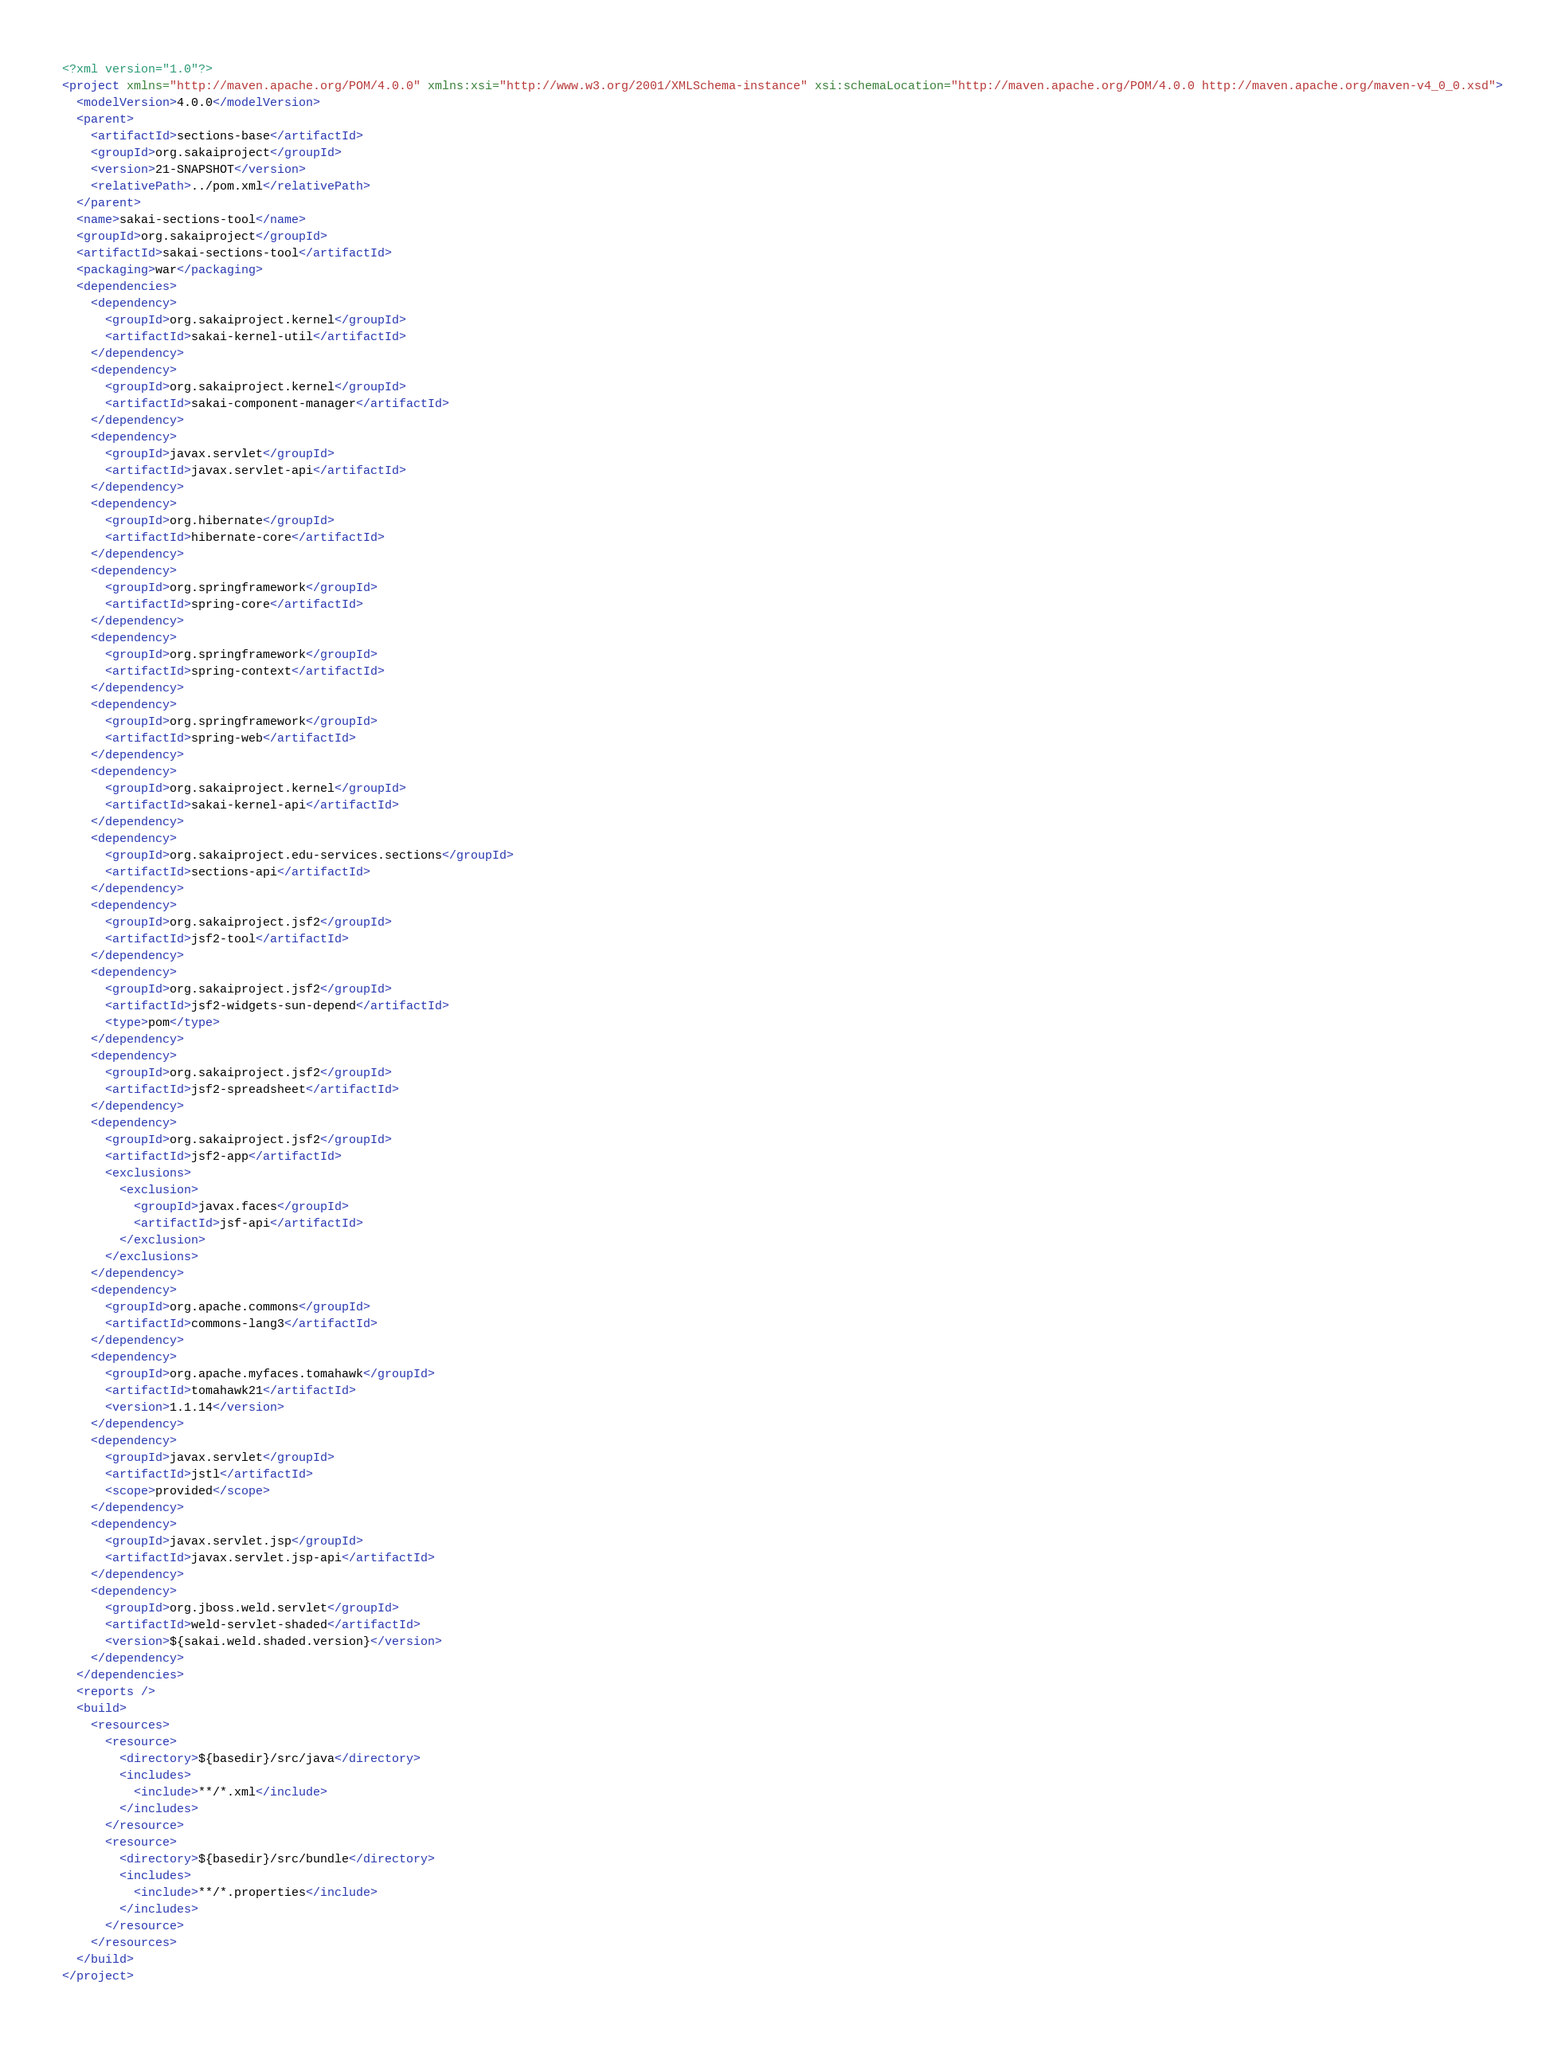Convert code to text. <code><loc_0><loc_0><loc_500><loc_500><_XML_><?xml version="1.0"?>
<project xmlns="http://maven.apache.org/POM/4.0.0" xmlns:xsi="http://www.w3.org/2001/XMLSchema-instance" xsi:schemaLocation="http://maven.apache.org/POM/4.0.0 http://maven.apache.org/maven-v4_0_0.xsd">
  <modelVersion>4.0.0</modelVersion>
  <parent>
    <artifactId>sections-base</artifactId>
    <groupId>org.sakaiproject</groupId>
    <version>21-SNAPSHOT</version>
    <relativePath>../pom.xml</relativePath>
  </parent>
  <name>sakai-sections-tool</name>
  <groupId>org.sakaiproject</groupId>
  <artifactId>sakai-sections-tool</artifactId>
  <packaging>war</packaging>
  <dependencies>
    <dependency>
      <groupId>org.sakaiproject.kernel</groupId>
      <artifactId>sakai-kernel-util</artifactId>
    </dependency>
    <dependency>
      <groupId>org.sakaiproject.kernel</groupId>
      <artifactId>sakai-component-manager</artifactId>
    </dependency>
    <dependency>
      <groupId>javax.servlet</groupId>
      <artifactId>javax.servlet-api</artifactId>
    </dependency>
    <dependency>
      <groupId>org.hibernate</groupId>
      <artifactId>hibernate-core</artifactId>
    </dependency>
    <dependency>
      <groupId>org.springframework</groupId>
      <artifactId>spring-core</artifactId>
    </dependency>
    <dependency>
      <groupId>org.springframework</groupId>
      <artifactId>spring-context</artifactId>
    </dependency>
    <dependency>
      <groupId>org.springframework</groupId>
      <artifactId>spring-web</artifactId>
    </dependency>
    <dependency>
      <groupId>org.sakaiproject.kernel</groupId>
      <artifactId>sakai-kernel-api</artifactId>
    </dependency>
    <dependency>
      <groupId>org.sakaiproject.edu-services.sections</groupId>
      <artifactId>sections-api</artifactId>
    </dependency>
    <dependency>
      <groupId>org.sakaiproject.jsf2</groupId>
      <artifactId>jsf2-tool</artifactId>
    </dependency>
    <dependency>
      <groupId>org.sakaiproject.jsf2</groupId>
      <artifactId>jsf2-widgets-sun-depend</artifactId>
      <type>pom</type>
    </dependency>
    <dependency>
      <groupId>org.sakaiproject.jsf2</groupId>
      <artifactId>jsf2-spreadsheet</artifactId>
    </dependency>
    <dependency>
      <groupId>org.sakaiproject.jsf2</groupId>
      <artifactId>jsf2-app</artifactId>
      <exclusions>
        <exclusion>
          <groupId>javax.faces</groupId>
          <artifactId>jsf-api</artifactId>
        </exclusion>
      </exclusions>
    </dependency>
    <dependency>
      <groupId>org.apache.commons</groupId>
      <artifactId>commons-lang3</artifactId>
    </dependency>
    <dependency>
      <groupId>org.apache.myfaces.tomahawk</groupId>
      <artifactId>tomahawk21</artifactId>
      <version>1.1.14</version>
    </dependency>
    <dependency>
      <groupId>javax.servlet</groupId>
      <artifactId>jstl</artifactId>
      <scope>provided</scope>
    </dependency>
    <dependency>
      <groupId>javax.servlet.jsp</groupId>
      <artifactId>javax.servlet.jsp-api</artifactId>
    </dependency>
    <dependency>
      <groupId>org.jboss.weld.servlet</groupId>
      <artifactId>weld-servlet-shaded</artifactId>
      <version>${sakai.weld.shaded.version}</version>
    </dependency>
  </dependencies>
  <reports />
  <build>
    <resources>
      <resource>
        <directory>${basedir}/src/java</directory>
        <includes>
          <include>**/*.xml</include>
        </includes>
      </resource>
      <resource>
        <directory>${basedir}/src/bundle</directory>
        <includes>
          <include>**/*.properties</include>
        </includes>
      </resource>
    </resources>
  </build>
</project>
</code> 